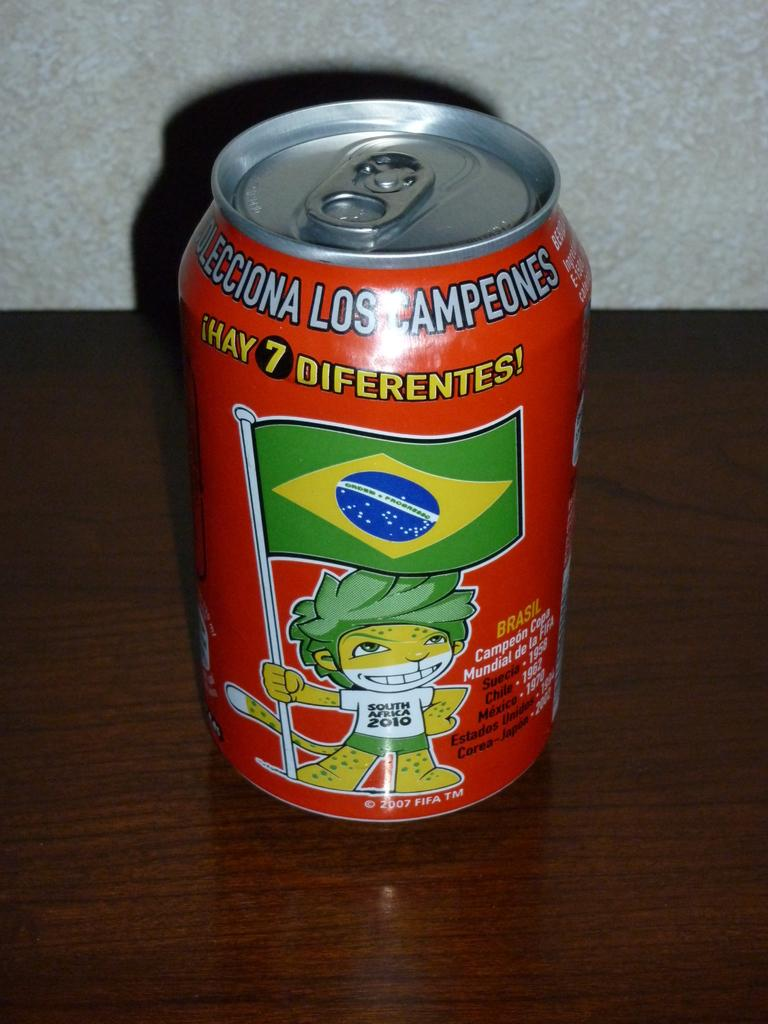<image>
Create a compact narrative representing the image presented. A can of drink that says Los Ampeones on it. 